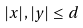<formula> <loc_0><loc_0><loc_500><loc_500>| x | , | y | \leq d</formula> 